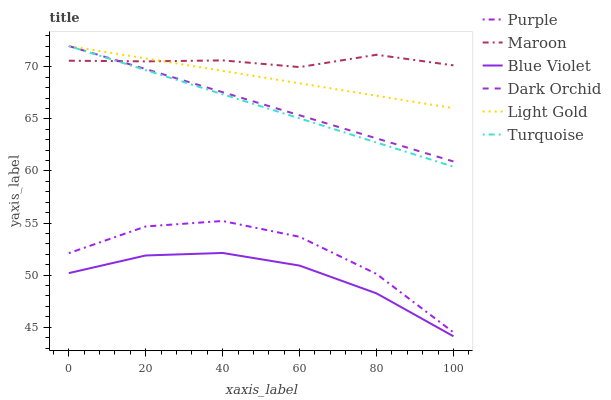Does Blue Violet have the minimum area under the curve?
Answer yes or no. Yes. Does Maroon have the maximum area under the curve?
Answer yes or no. Yes. Does Purple have the minimum area under the curve?
Answer yes or no. No. Does Purple have the maximum area under the curve?
Answer yes or no. No. Is Dark Orchid the smoothest?
Answer yes or no. Yes. Is Purple the roughest?
Answer yes or no. Yes. Is Purple the smoothest?
Answer yes or no. No. Is Dark Orchid the roughest?
Answer yes or no. No. Does Purple have the lowest value?
Answer yes or no. No. Does Purple have the highest value?
Answer yes or no. No. Is Blue Violet less than Dark Orchid?
Answer yes or no. Yes. Is Purple greater than Blue Violet?
Answer yes or no. Yes. Does Blue Violet intersect Dark Orchid?
Answer yes or no. No. 